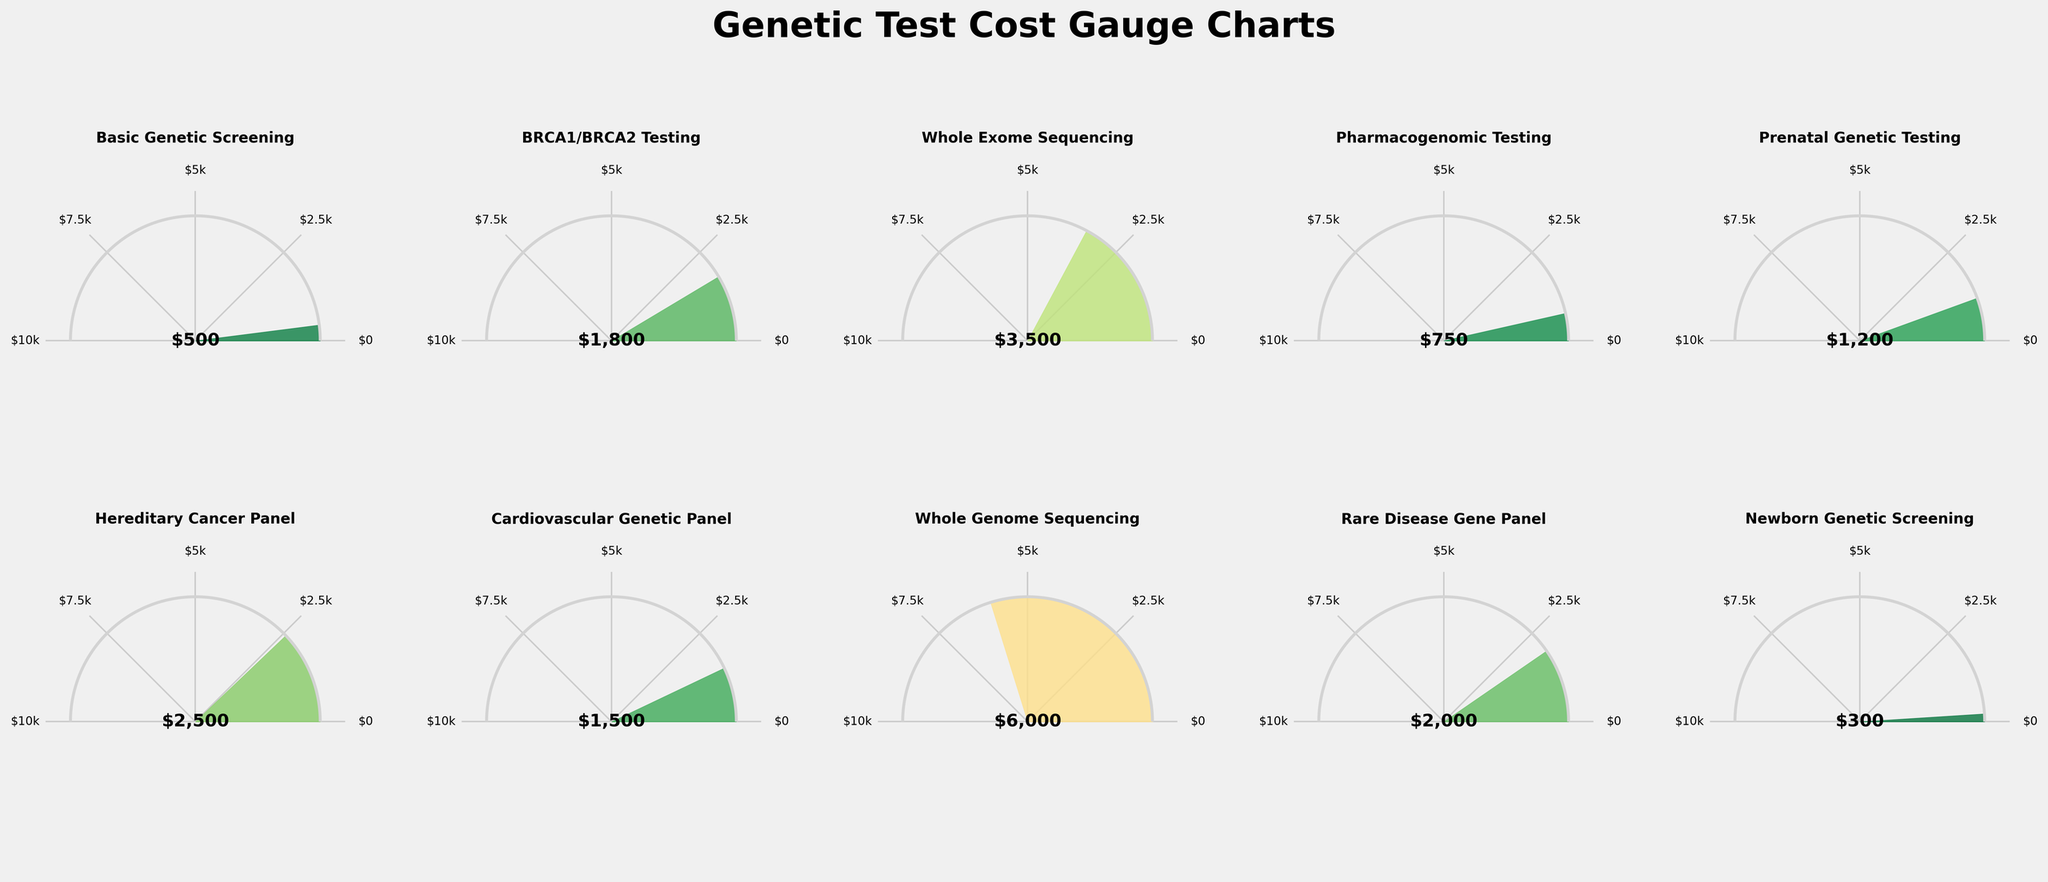What is the title of the figure? The title is displayed at the top of the figure in a larger font, which reads "Genetic Test Cost Gauge Charts".
Answer: Genetic Test Cost Gauge Charts Which genetic test has the lowest cost? The gauge with the lowest fill, farthest to the left, corresponds to Newborn Genetic Screening with a cost of $300.
Answer: Newborn Genetic Screening What is the average cost of all the genetic tests? Sum all the displayed costs ($500 + $1800 + $3500 + $750 + $1200 + $2500 + $1500 + $6000 + $2000 + $300) = $20,050. Then, divide by the number of tests (10). The average cost is $20,050 / 10 = $2,005.
Answer: $2,005 Which genetic test(s) cost more than $3,000? Identify the tests where the gauge exceeds the $3,000 mark. These are Whole Exome Sequencing ($3,500) and Whole Genome Sequencing ($6,000).
Answer: Whole Exome Sequencing, Whole Genome Sequencing What is the average cost of BRCA1/BRCA2 Testing and Hereditary Cancer Panel? Sum the costs of BRCA1/BRCA2 Testing ($1,800) and Hereditary Cancer Panel ($2,500). Then, divide by 2. ($1,800 + $2,500) / 2 = $2,150.
Answer: $2,150 Is Pharmacogenomic Testing more expensive than Prenatal Genetic Testing? Compare the two costs: Pharmacogenomic Testing is $750 and Prenatal Genetic Testing is $1,200. Since $750 < $1,200, Pharmacogenomic Testing is less expensive.
Answer: No How many genetic tests have a cost of $2,000 or more? Count the gauges indicating costs $2,000 or more: BRCA1/BRCA2 Testing ($1,800, excluded), Whole Exome Sequencing ($3,500), Hereditary Cancer Panel ($2,500), Whole Genome Sequencing ($6,000), Rare Disease Gene Panel ($2,000). There are 4 tests.
Answer: 4 What is the total cost of Basic Genetic Screening and Cardiovascular Genetic Panel? Sum the costs of Basic Genetic Screening ($500) and Cardiovascular Genetic Panel ($1,500). $500 + $1,500 = $2,000.
Answer: $2,000 How much more expensive is Whole Genome Sequencing compared to Rare Disease Gene Panel? Subtract the cost of Rare Disease Gene Panel ($2,000) from the cost of Whole Genome Sequencing ($6,000). $6,000 - $2,000 = $4,000.
Answer: $4,000 